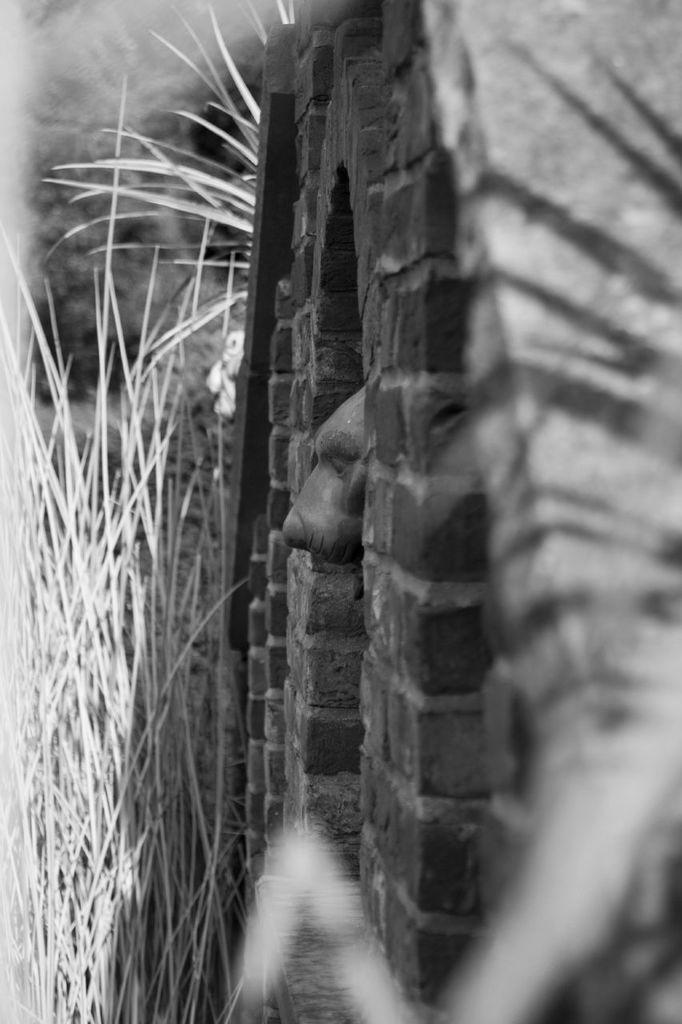How would you summarize this image in a sentence or two? This is black and white image. Where we can see a dog kept its head out from the stone wall. Here we can see the grass. 